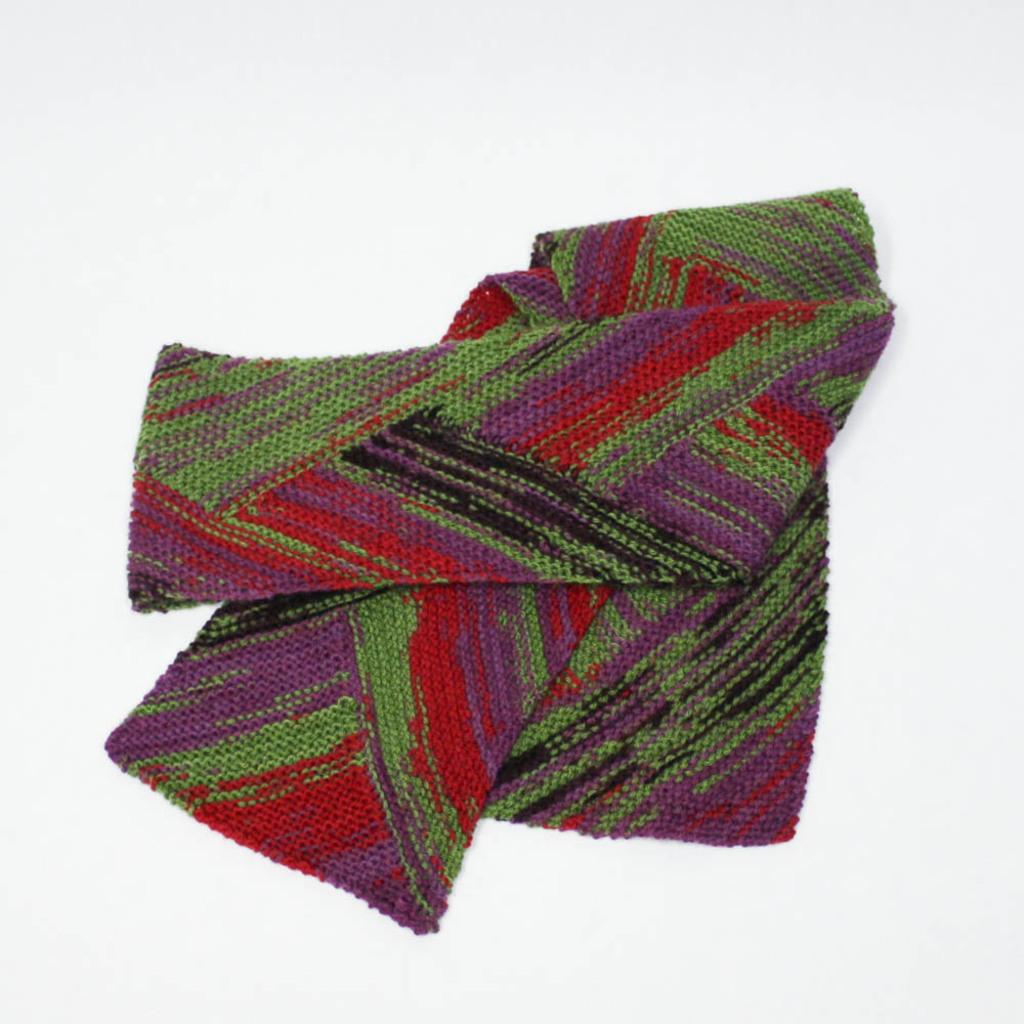What is the main object in the image? There is a cloth in the image. What colors can be seen on the cloth? The cloth has a combination of red, violet, green, and black colors. Where is the cloth located in the image? The cloth is on a surface. What color is the background of the image? The background of the image is white. Can you solve the riddle written on the cloth in the image? There is no riddle written on the cloth in the image; it is a piece of fabric with colors. How can we help the deer that is not present in the image? There is no deer present in the image, so we cannot help it. 